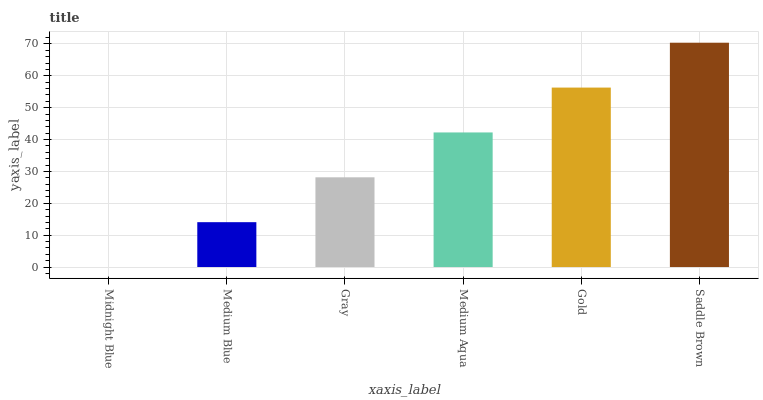Is Midnight Blue the minimum?
Answer yes or no. Yes. Is Saddle Brown the maximum?
Answer yes or no. Yes. Is Medium Blue the minimum?
Answer yes or no. No. Is Medium Blue the maximum?
Answer yes or no. No. Is Medium Blue greater than Midnight Blue?
Answer yes or no. Yes. Is Midnight Blue less than Medium Blue?
Answer yes or no. Yes. Is Midnight Blue greater than Medium Blue?
Answer yes or no. No. Is Medium Blue less than Midnight Blue?
Answer yes or no. No. Is Medium Aqua the high median?
Answer yes or no. Yes. Is Gray the low median?
Answer yes or no. Yes. Is Midnight Blue the high median?
Answer yes or no. No. Is Medium Blue the low median?
Answer yes or no. No. 